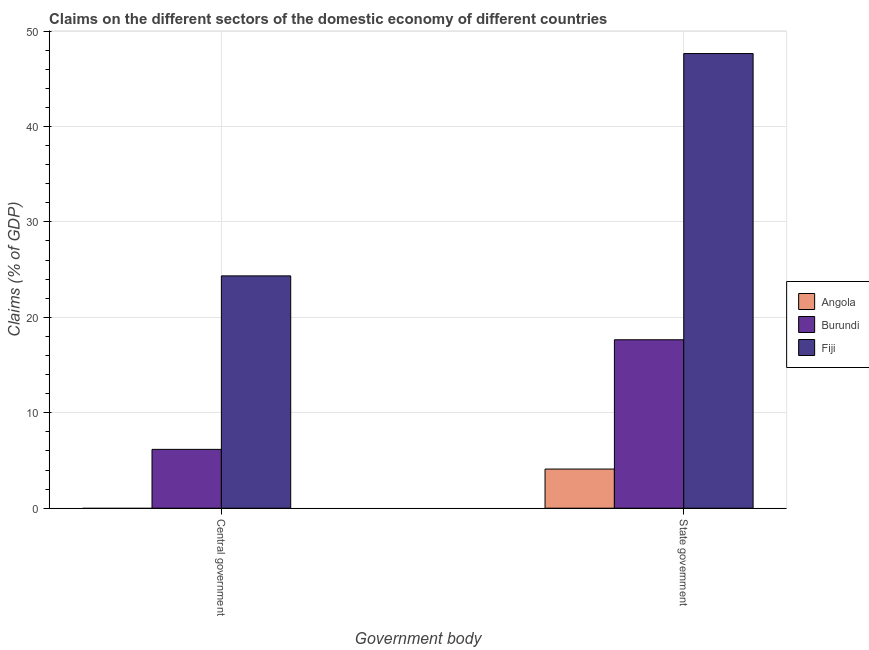How many different coloured bars are there?
Your answer should be very brief. 3. How many bars are there on the 2nd tick from the left?
Provide a short and direct response. 3. What is the label of the 1st group of bars from the left?
Your answer should be compact. Central government. What is the claims on state government in Fiji?
Provide a succinct answer. 47.64. Across all countries, what is the maximum claims on central government?
Your answer should be very brief. 24.34. Across all countries, what is the minimum claims on state government?
Keep it short and to the point. 4.1. In which country was the claims on central government maximum?
Your answer should be compact. Fiji. What is the total claims on central government in the graph?
Your answer should be very brief. 30.51. What is the difference between the claims on state government in Angola and that in Burundi?
Provide a succinct answer. -13.55. What is the difference between the claims on central government in Burundi and the claims on state government in Fiji?
Keep it short and to the point. -41.48. What is the average claims on state government per country?
Your response must be concise. 23.13. What is the difference between the claims on state government and claims on central government in Burundi?
Ensure brevity in your answer.  11.49. What is the ratio of the claims on state government in Angola to that in Fiji?
Give a very brief answer. 0.09. Does the graph contain any zero values?
Your response must be concise. Yes. Where does the legend appear in the graph?
Your answer should be compact. Center right. How many legend labels are there?
Offer a very short reply. 3. How are the legend labels stacked?
Keep it short and to the point. Vertical. What is the title of the graph?
Ensure brevity in your answer.  Claims on the different sectors of the domestic economy of different countries. Does "Azerbaijan" appear as one of the legend labels in the graph?
Make the answer very short. No. What is the label or title of the X-axis?
Give a very brief answer. Government body. What is the label or title of the Y-axis?
Offer a very short reply. Claims (% of GDP). What is the Claims (% of GDP) of Burundi in Central government?
Your answer should be very brief. 6.16. What is the Claims (% of GDP) in Fiji in Central government?
Offer a very short reply. 24.34. What is the Claims (% of GDP) of Angola in State government?
Your response must be concise. 4.1. What is the Claims (% of GDP) of Burundi in State government?
Your answer should be very brief. 17.65. What is the Claims (% of GDP) of Fiji in State government?
Provide a short and direct response. 47.64. Across all Government body, what is the maximum Claims (% of GDP) of Angola?
Give a very brief answer. 4.1. Across all Government body, what is the maximum Claims (% of GDP) in Burundi?
Make the answer very short. 17.65. Across all Government body, what is the maximum Claims (% of GDP) in Fiji?
Give a very brief answer. 47.64. Across all Government body, what is the minimum Claims (% of GDP) of Burundi?
Ensure brevity in your answer.  6.16. Across all Government body, what is the minimum Claims (% of GDP) of Fiji?
Your answer should be very brief. 24.34. What is the total Claims (% of GDP) of Angola in the graph?
Provide a short and direct response. 4.1. What is the total Claims (% of GDP) in Burundi in the graph?
Keep it short and to the point. 23.81. What is the total Claims (% of GDP) in Fiji in the graph?
Offer a very short reply. 71.98. What is the difference between the Claims (% of GDP) of Burundi in Central government and that in State government?
Offer a very short reply. -11.49. What is the difference between the Claims (% of GDP) of Fiji in Central government and that in State government?
Your answer should be very brief. -23.3. What is the difference between the Claims (% of GDP) of Burundi in Central government and the Claims (% of GDP) of Fiji in State government?
Give a very brief answer. -41.48. What is the average Claims (% of GDP) of Angola per Government body?
Your response must be concise. 2.05. What is the average Claims (% of GDP) in Burundi per Government body?
Your answer should be compact. 11.91. What is the average Claims (% of GDP) in Fiji per Government body?
Make the answer very short. 35.99. What is the difference between the Claims (% of GDP) in Burundi and Claims (% of GDP) in Fiji in Central government?
Ensure brevity in your answer.  -18.18. What is the difference between the Claims (% of GDP) in Angola and Claims (% of GDP) in Burundi in State government?
Your answer should be very brief. -13.55. What is the difference between the Claims (% of GDP) of Angola and Claims (% of GDP) of Fiji in State government?
Ensure brevity in your answer.  -43.54. What is the difference between the Claims (% of GDP) of Burundi and Claims (% of GDP) of Fiji in State government?
Give a very brief answer. -29.99. What is the ratio of the Claims (% of GDP) of Burundi in Central government to that in State government?
Provide a short and direct response. 0.35. What is the ratio of the Claims (% of GDP) in Fiji in Central government to that in State government?
Ensure brevity in your answer.  0.51. What is the difference between the highest and the second highest Claims (% of GDP) of Burundi?
Make the answer very short. 11.49. What is the difference between the highest and the second highest Claims (% of GDP) of Fiji?
Make the answer very short. 23.3. What is the difference between the highest and the lowest Claims (% of GDP) of Angola?
Provide a short and direct response. 4.1. What is the difference between the highest and the lowest Claims (% of GDP) of Burundi?
Offer a terse response. 11.49. What is the difference between the highest and the lowest Claims (% of GDP) of Fiji?
Offer a very short reply. 23.3. 